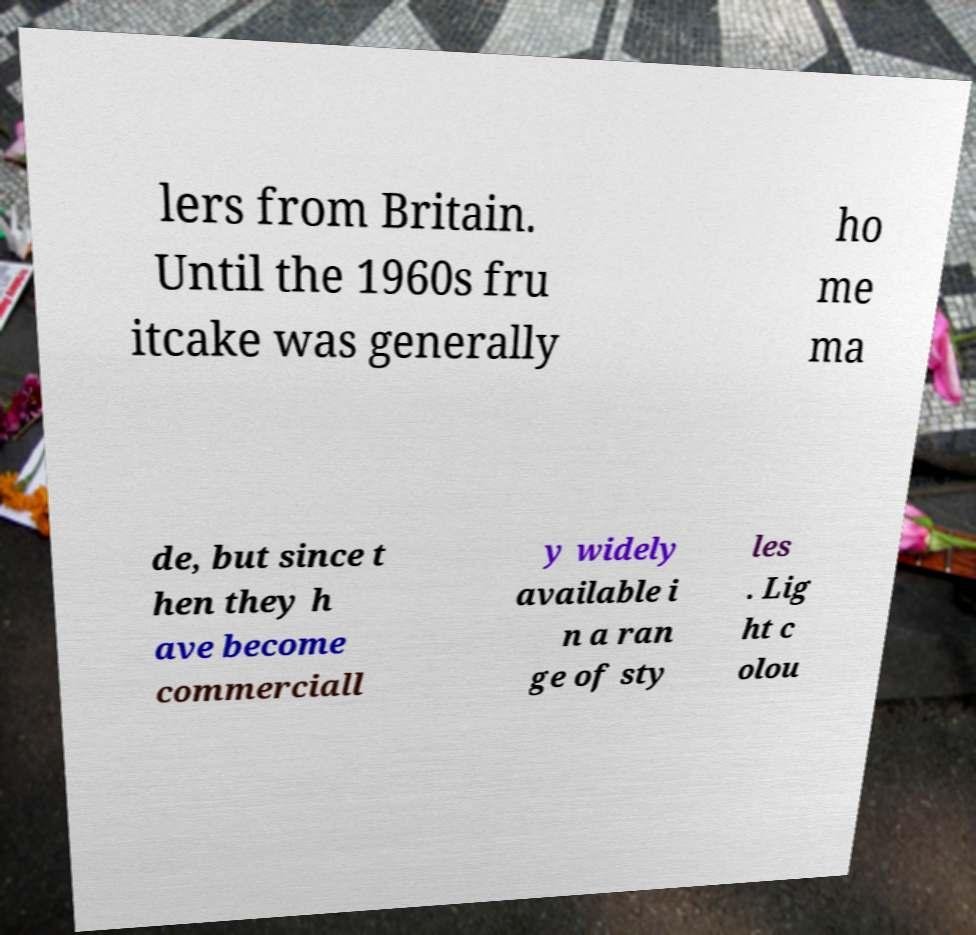Can you accurately transcribe the text from the provided image for me? lers from Britain. Until the 1960s fru itcake was generally ho me ma de, but since t hen they h ave become commerciall y widely available i n a ran ge of sty les . Lig ht c olou 